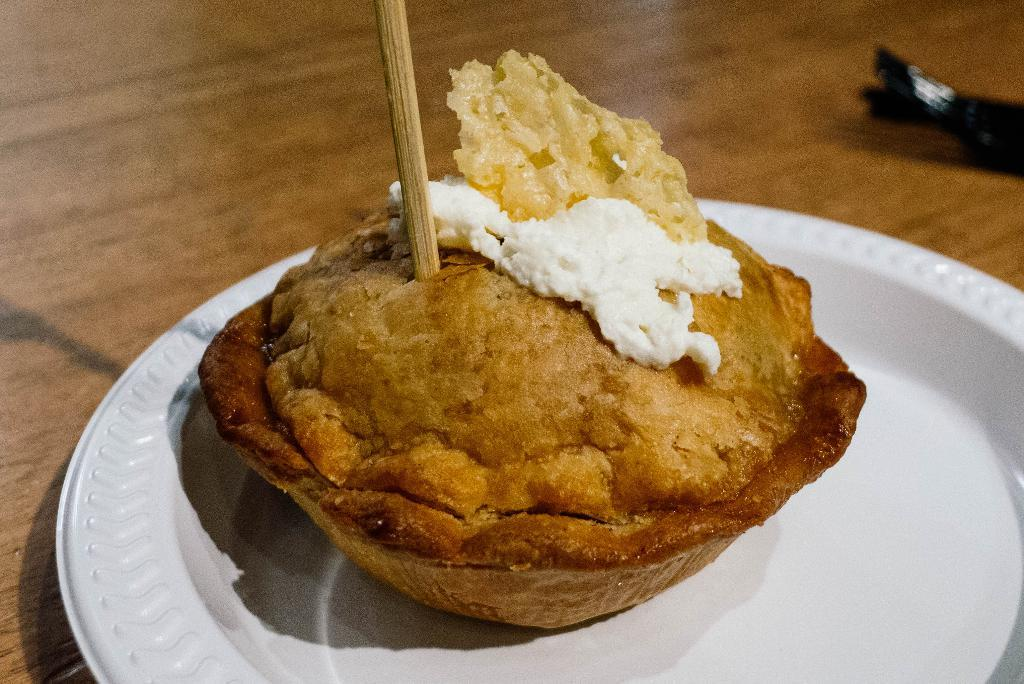What type of food can be seen in the image? There is food in the image, but the specific type is not mentioned. What object is placed alongside the food in the image? There is a stick in the image, which is placed alongside the food. How are the food and stick arranged in the image? The food and stick are placed in a plate in the image. Where is the plate located in the image? The plate is on a table in the image. What type of metal is used to create the list in the image? There is no list present in the image, so it is not possible to determine the type of metal used to create it. 